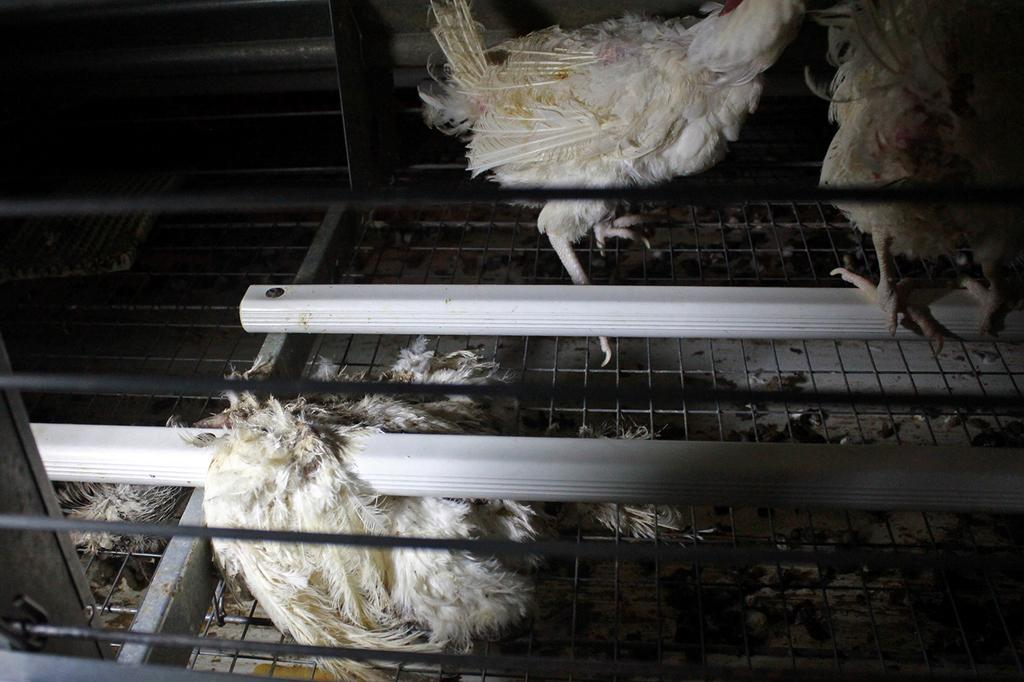What type of animals are in the image? There are hens in the image. What are the hens standing on in the image? The hens are on iron grills. What thrill can be experienced by the hens in the image? There is no indication in the image that the hens are experiencing any thrill. Is there any quicksand present in the image? There is no quicksand present in the image. 